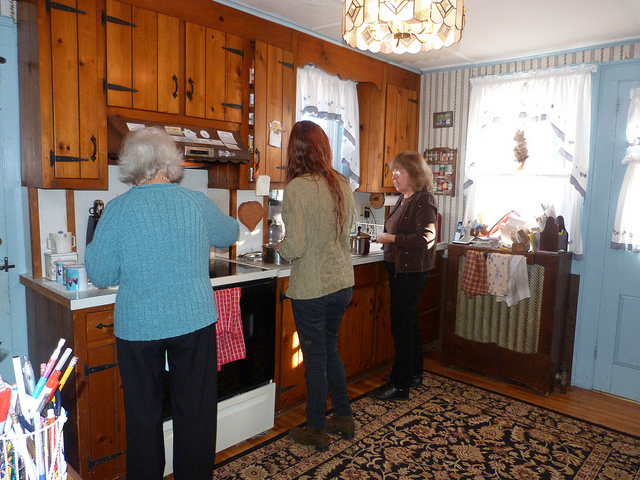What does this scene suggest about the relationship between the people? The scene suggests a comfortable and familiar dynamic between the individuals, likely indicating they are family or close friends. The informal setting and proximity in which they conduct their tasks suggest an ease and intimacy in their interactions. 